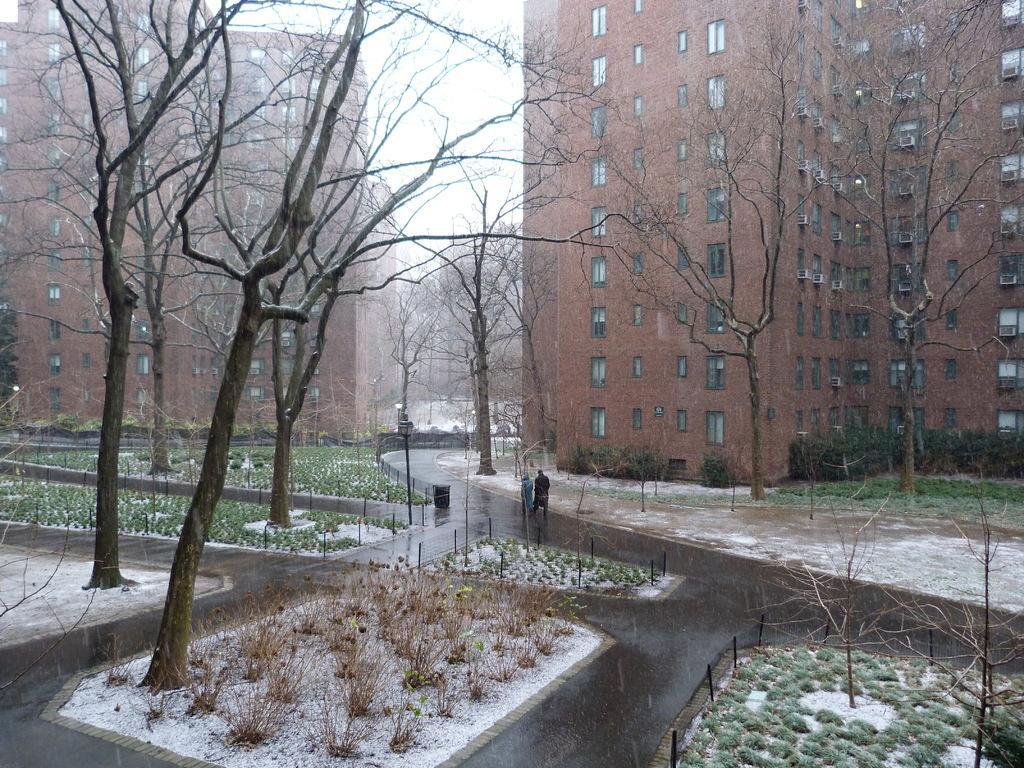Can you describe this image briefly? At the bottom of the image there are roads. There are two persons walking on the road. And also on the ground there is grass and also there are trees and fencing. Behind the trees there are buildings with walls and windows. 